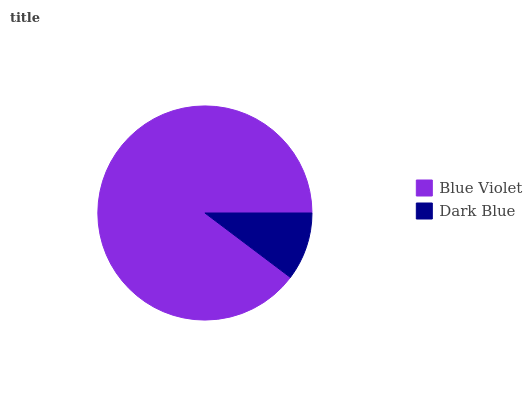Is Dark Blue the minimum?
Answer yes or no. Yes. Is Blue Violet the maximum?
Answer yes or no. Yes. Is Dark Blue the maximum?
Answer yes or no. No. Is Blue Violet greater than Dark Blue?
Answer yes or no. Yes. Is Dark Blue less than Blue Violet?
Answer yes or no. Yes. Is Dark Blue greater than Blue Violet?
Answer yes or no. No. Is Blue Violet less than Dark Blue?
Answer yes or no. No. Is Blue Violet the high median?
Answer yes or no. Yes. Is Dark Blue the low median?
Answer yes or no. Yes. Is Dark Blue the high median?
Answer yes or no. No. Is Blue Violet the low median?
Answer yes or no. No. 